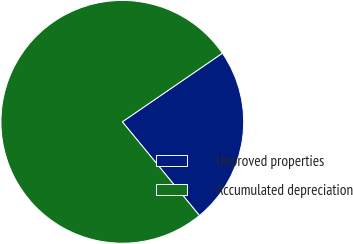<chart> <loc_0><loc_0><loc_500><loc_500><pie_chart><fcel>Unproved properties<fcel>Accumulated depreciation<nl><fcel>23.61%<fcel>76.39%<nl></chart> 